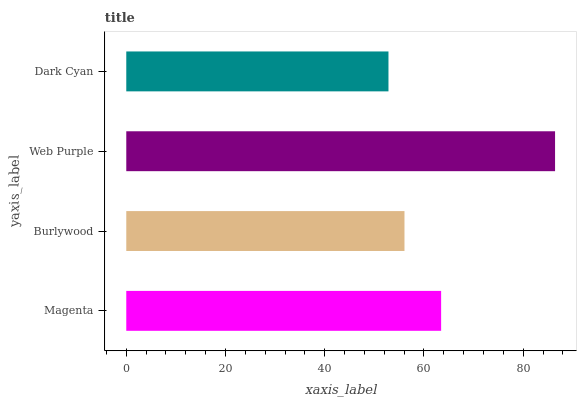Is Dark Cyan the minimum?
Answer yes or no. Yes. Is Web Purple the maximum?
Answer yes or no. Yes. Is Burlywood the minimum?
Answer yes or no. No. Is Burlywood the maximum?
Answer yes or no. No. Is Magenta greater than Burlywood?
Answer yes or no. Yes. Is Burlywood less than Magenta?
Answer yes or no. Yes. Is Burlywood greater than Magenta?
Answer yes or no. No. Is Magenta less than Burlywood?
Answer yes or no. No. Is Magenta the high median?
Answer yes or no. Yes. Is Burlywood the low median?
Answer yes or no. Yes. Is Dark Cyan the high median?
Answer yes or no. No. Is Magenta the low median?
Answer yes or no. No. 